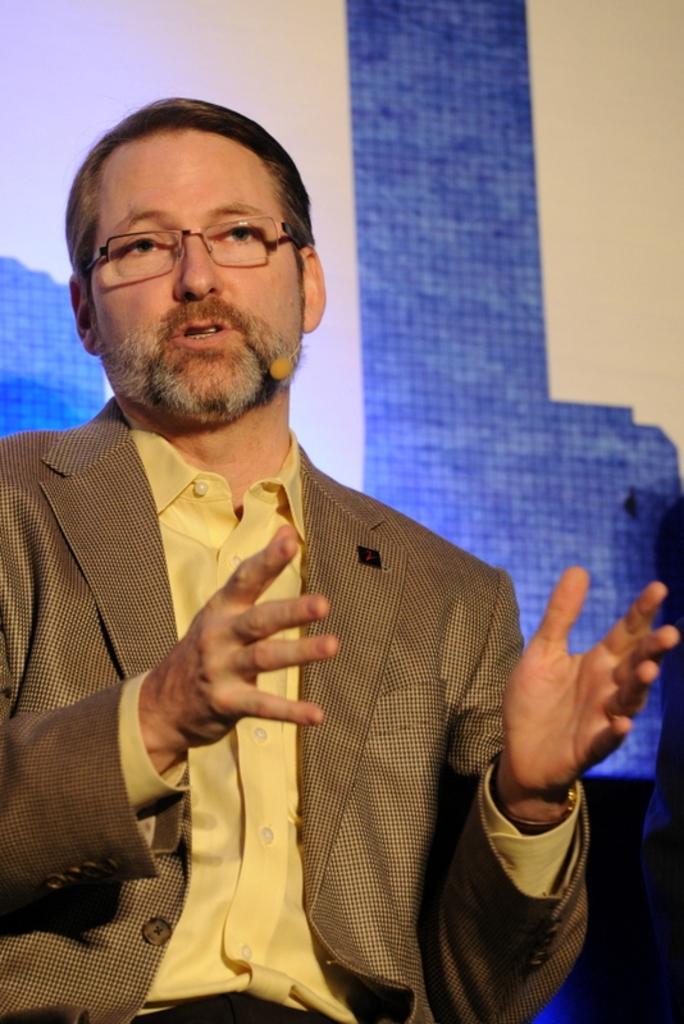Can you describe this image briefly? A person wore a mic, spectacles and he is talking. Background there is a blue and white wall. 